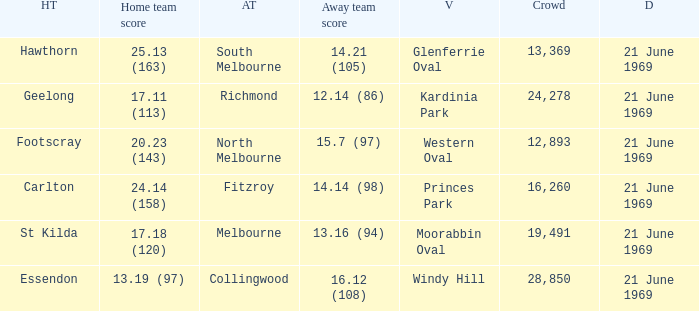When did an away team score 15.7 (97)? 21 June 1969. 